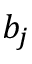<formula> <loc_0><loc_0><loc_500><loc_500>b _ { j }</formula> 